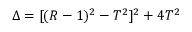<formula> <loc_0><loc_0><loc_500><loc_500>\Delta = [ ( R - 1 ) ^ { 2 } - T ^ { 2 } ] ^ { 2 } + 4 T ^ { 2 }</formula> 